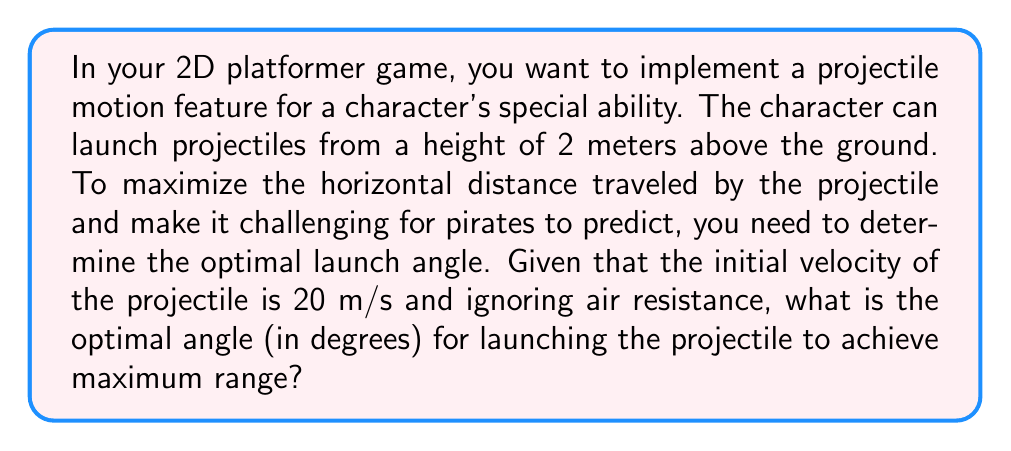Can you answer this question? To find the optimal angle for maximum range in projectile motion, we can follow these steps:

1. The general equation for the range (R) of a projectile launched from height h is:

   $$R = \frac{v_0^2}{g} \left(\sin(2\theta) + \sqrt{\sin^2(2\theta) + \frac{2gh}{v_0^2}}\right)$$

   Where:
   $v_0$ is the initial velocity
   $g$ is the acceleration due to gravity (9.8 m/s²)
   $\theta$ is the launch angle
   $h$ is the initial height

2. For a projectile launched from ground level (h = 0), the optimal angle is always 45°. However, when launched from a height, the optimal angle is slightly less than 45°.

3. To find the exact angle, we need to differentiate the range equation with respect to $\theta$ and set it to zero. However, this leads to a complex equation that's difficult to solve analytically.

4. Instead, we can use the approximation formula for the optimal angle when launched from a height:

   $$\theta_{optimal} \approx 45° - \frac{1}{4} \arcsin\left(\frac{gh}{v_0^2}\right)$$

5. Let's plug in our values:
   $g = 9.8$ m/s²
   $h = 2$ m
   $v_0 = 20$ m/s

6. Calculate:
   $$\theta_{optimal} \approx 45° - \frac{1}{4} \arcsin\left(\frac{9.8 \times 2}{20^2}\right)$$
   $$\theta_{optimal} \approx 45° - \frac{1}{4} \arcsin(0.049)$$
   $$\theta_{optimal} \approx 45° - \frac{1}{4} \times 2.81°$$
   $$\theta_{optimal} \approx 45° - 0.70°$$
   $$\theta_{optimal} \approx 44.30°$$

7. Round to the nearest degree for practical implementation in the game.
Answer: 44° 